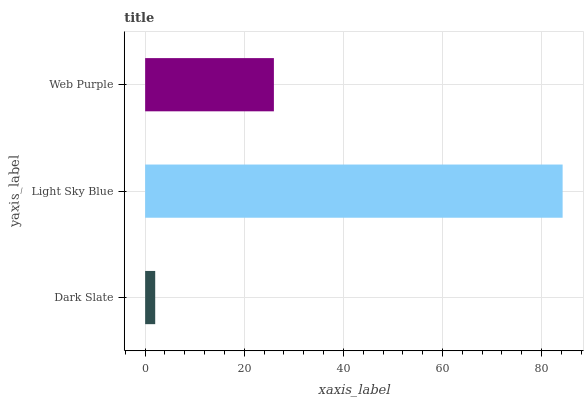Is Dark Slate the minimum?
Answer yes or no. Yes. Is Light Sky Blue the maximum?
Answer yes or no. Yes. Is Web Purple the minimum?
Answer yes or no. No. Is Web Purple the maximum?
Answer yes or no. No. Is Light Sky Blue greater than Web Purple?
Answer yes or no. Yes. Is Web Purple less than Light Sky Blue?
Answer yes or no. Yes. Is Web Purple greater than Light Sky Blue?
Answer yes or no. No. Is Light Sky Blue less than Web Purple?
Answer yes or no. No. Is Web Purple the high median?
Answer yes or no. Yes. Is Web Purple the low median?
Answer yes or no. Yes. Is Light Sky Blue the high median?
Answer yes or no. No. Is Light Sky Blue the low median?
Answer yes or no. No. 